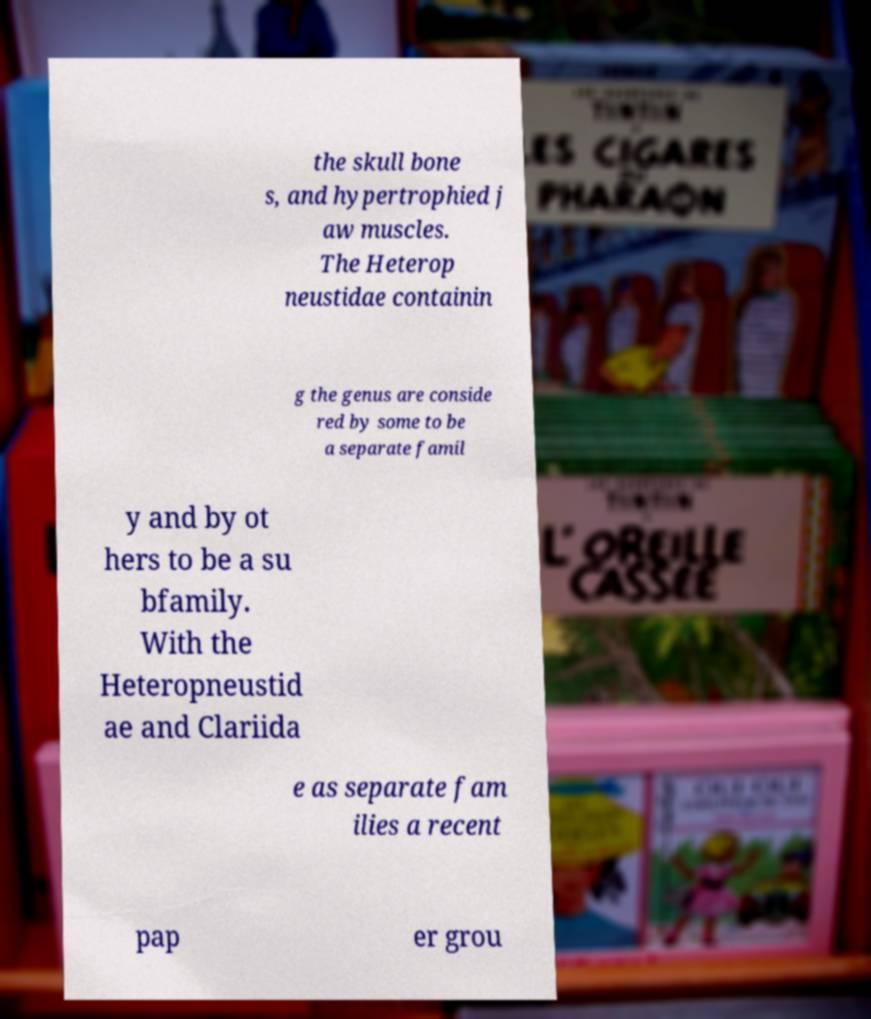Could you assist in decoding the text presented in this image and type it out clearly? the skull bone s, and hypertrophied j aw muscles. The Heterop neustidae containin g the genus are conside red by some to be a separate famil y and by ot hers to be a su bfamily. With the Heteropneustid ae and Clariida e as separate fam ilies a recent pap er grou 